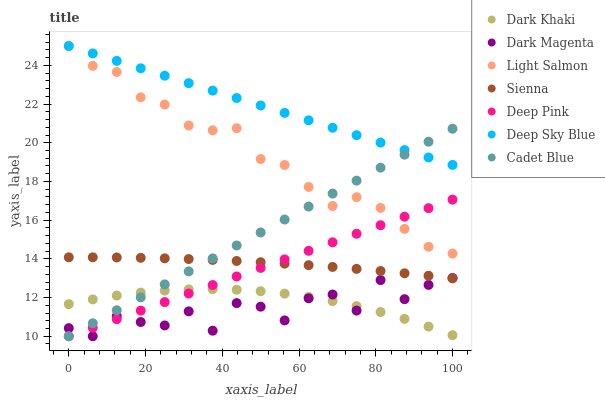Does Dark Magenta have the minimum area under the curve?
Answer yes or no. Yes. Does Deep Sky Blue have the maximum area under the curve?
Answer yes or no. Yes. Does Light Salmon have the minimum area under the curve?
Answer yes or no. No. Does Light Salmon have the maximum area under the curve?
Answer yes or no. No. Is Deep Pink the smoothest?
Answer yes or no. Yes. Is Dark Magenta the roughest?
Answer yes or no. Yes. Is Light Salmon the smoothest?
Answer yes or no. No. Is Light Salmon the roughest?
Answer yes or no. No. Does Deep Pink have the lowest value?
Answer yes or no. Yes. Does Light Salmon have the lowest value?
Answer yes or no. No. Does Deep Sky Blue have the highest value?
Answer yes or no. Yes. Does Deep Pink have the highest value?
Answer yes or no. No. Is Dark Magenta less than Light Salmon?
Answer yes or no. Yes. Is Light Salmon greater than Sienna?
Answer yes or no. Yes. Does Dark Magenta intersect Sienna?
Answer yes or no. Yes. Is Dark Magenta less than Sienna?
Answer yes or no. No. Is Dark Magenta greater than Sienna?
Answer yes or no. No. Does Dark Magenta intersect Light Salmon?
Answer yes or no. No. 